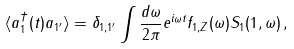<formula> <loc_0><loc_0><loc_500><loc_500>\langle a ^ { \dagger } _ { 1 } ( t ) a _ { 1 ^ { \prime } } \rangle = \delta _ { 1 , 1 ^ { \prime } } \int \frac { d \omega } { 2 \pi } e ^ { i \omega t } f _ { 1 , Z } ( \omega ) S _ { 1 } ( 1 , \omega ) \, ,</formula> 